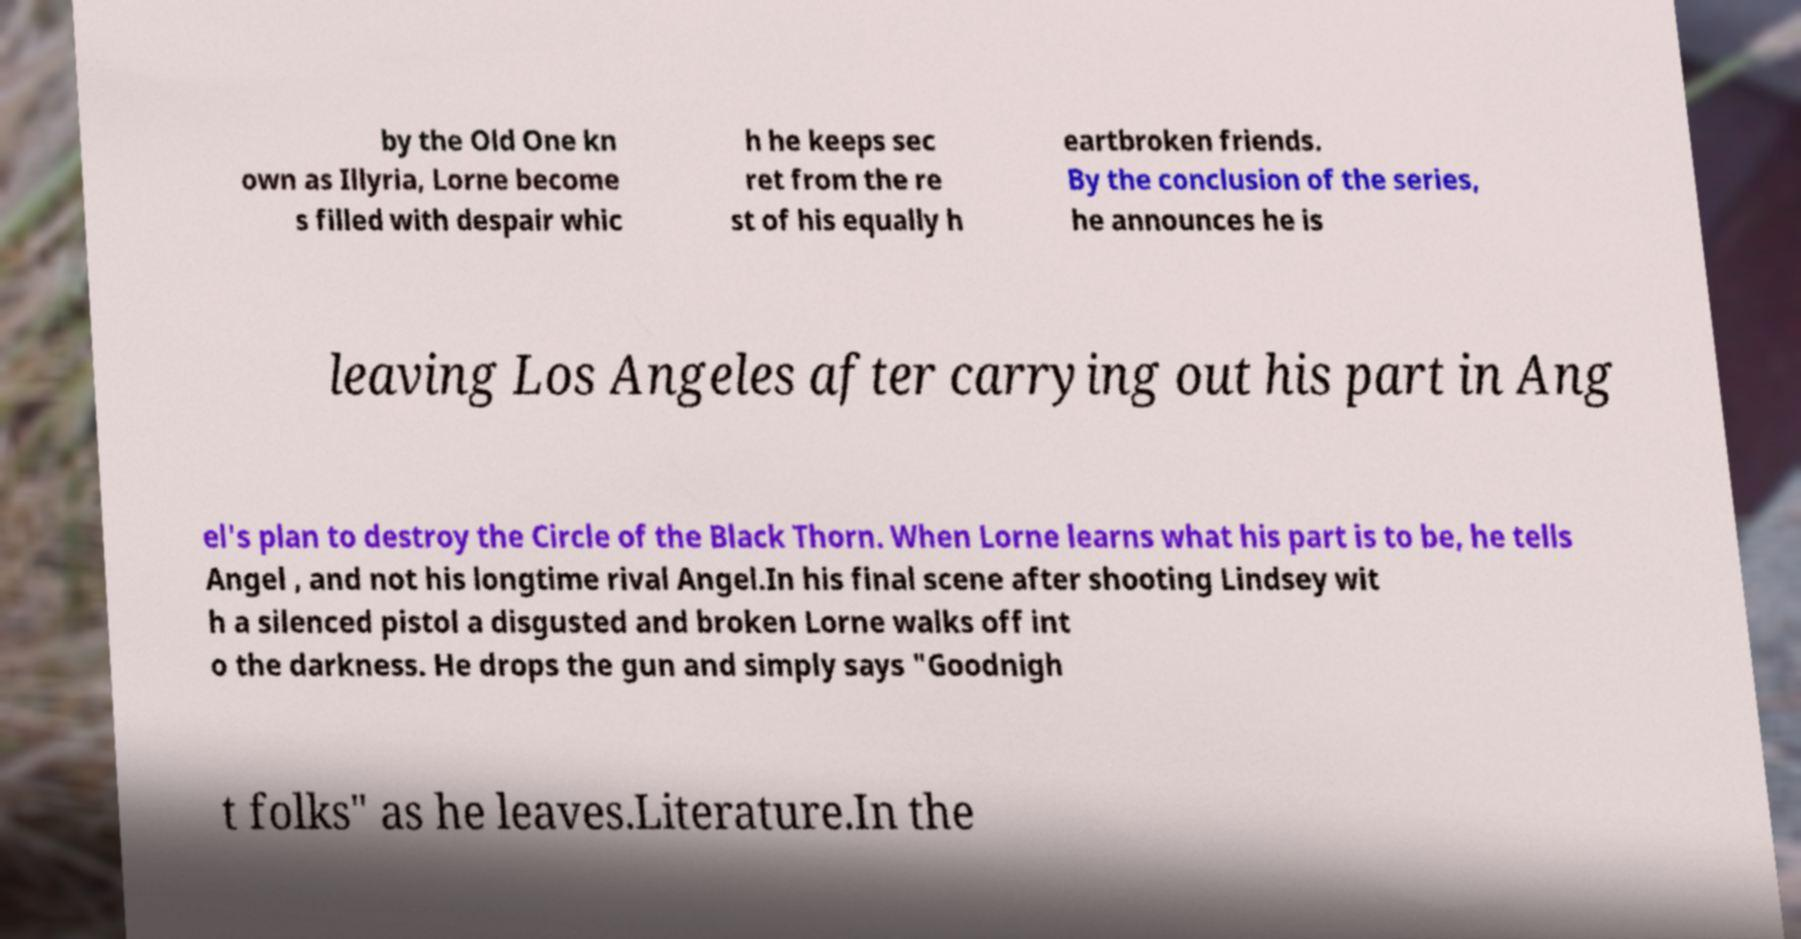Please identify and transcribe the text found in this image. by the Old One kn own as Illyria, Lorne become s filled with despair whic h he keeps sec ret from the re st of his equally h eartbroken friends. By the conclusion of the series, he announces he is leaving Los Angeles after carrying out his part in Ang el's plan to destroy the Circle of the Black Thorn. When Lorne learns what his part is to be, he tells Angel , and not his longtime rival Angel.In his final scene after shooting Lindsey wit h a silenced pistol a disgusted and broken Lorne walks off int o the darkness. He drops the gun and simply says "Goodnigh t folks" as he leaves.Literature.In the 